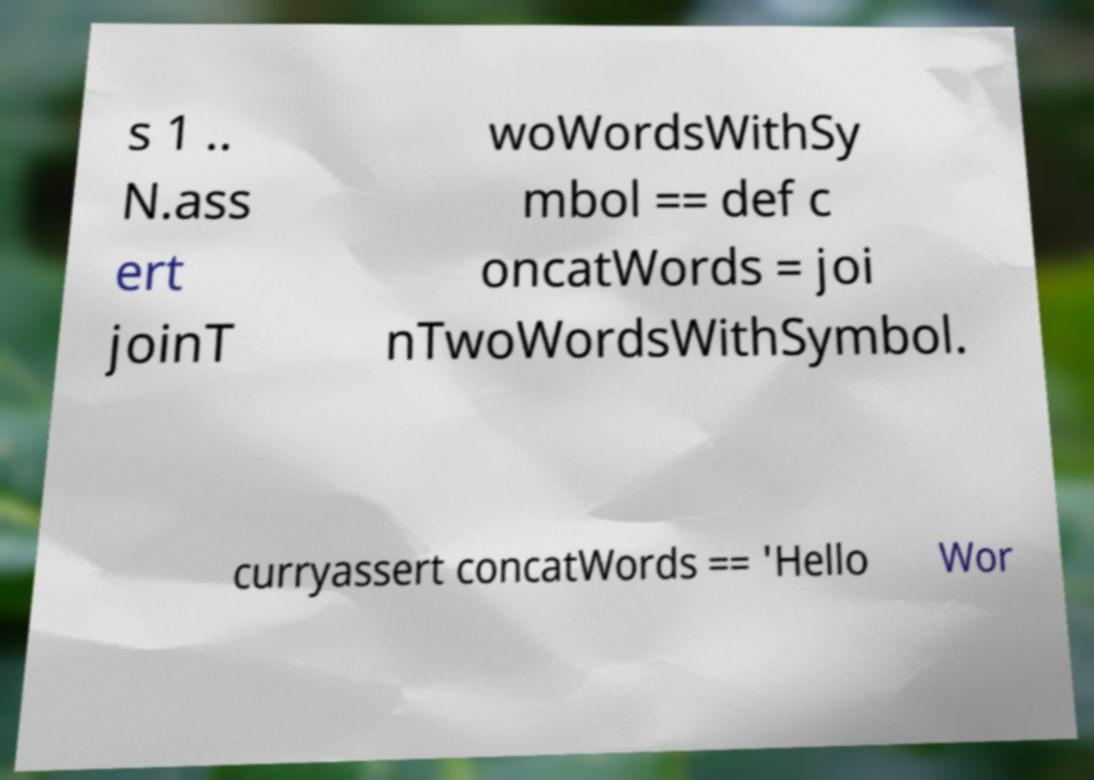For documentation purposes, I need the text within this image transcribed. Could you provide that? s 1 .. N.ass ert joinT woWordsWithSy mbol == def c oncatWords = joi nTwoWordsWithSymbol. curryassert concatWords == 'Hello Wor 